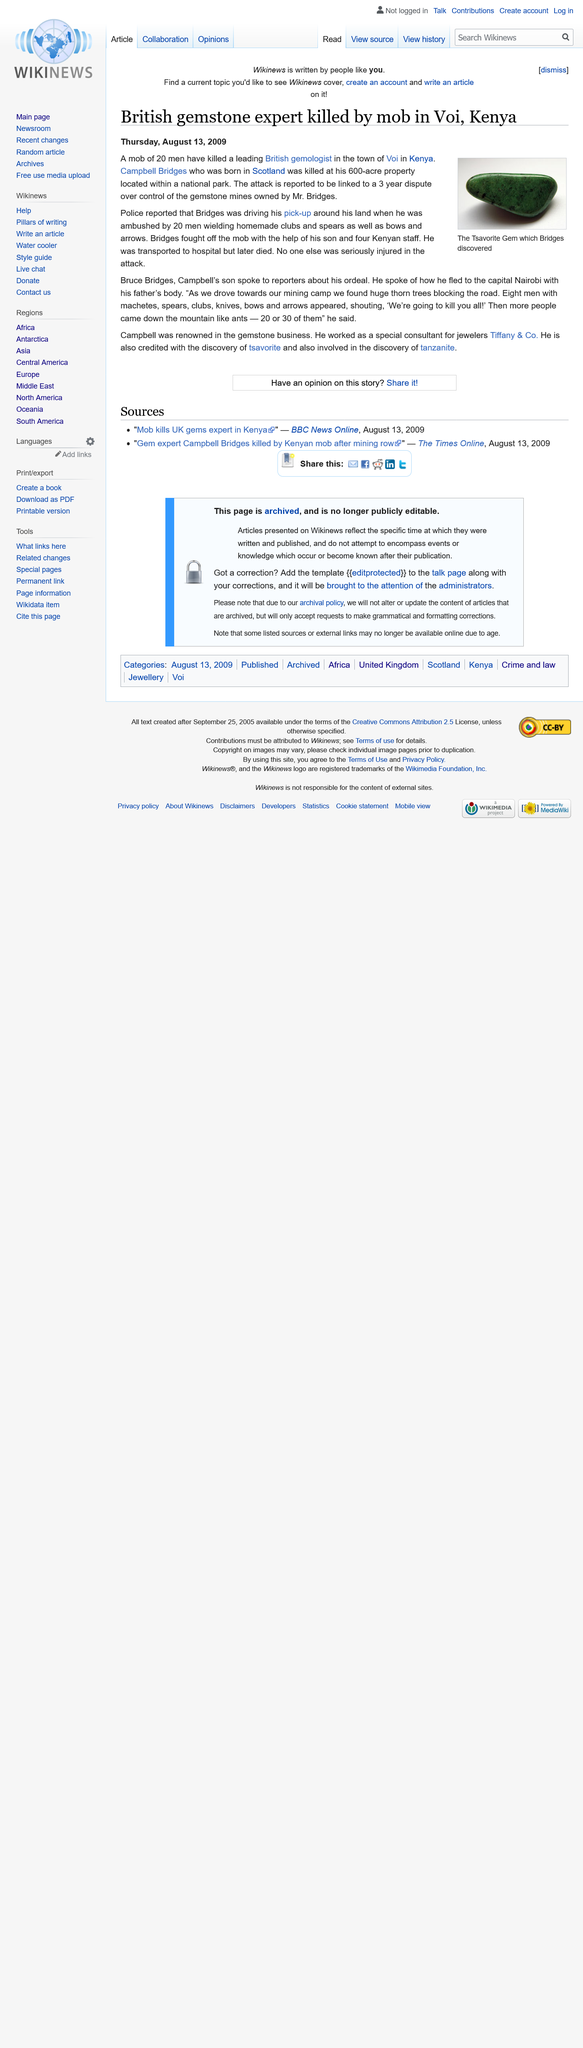Mention a couple of crucial points in this snapshot. Campbell Bridges, a gemstone expert who worked as a consultant for Tiffany & Co., was killed. Campbell Bridges' property was approximately 600 acres in size. Campbell was credited with the discovery of tsavorite, a gemstone. 